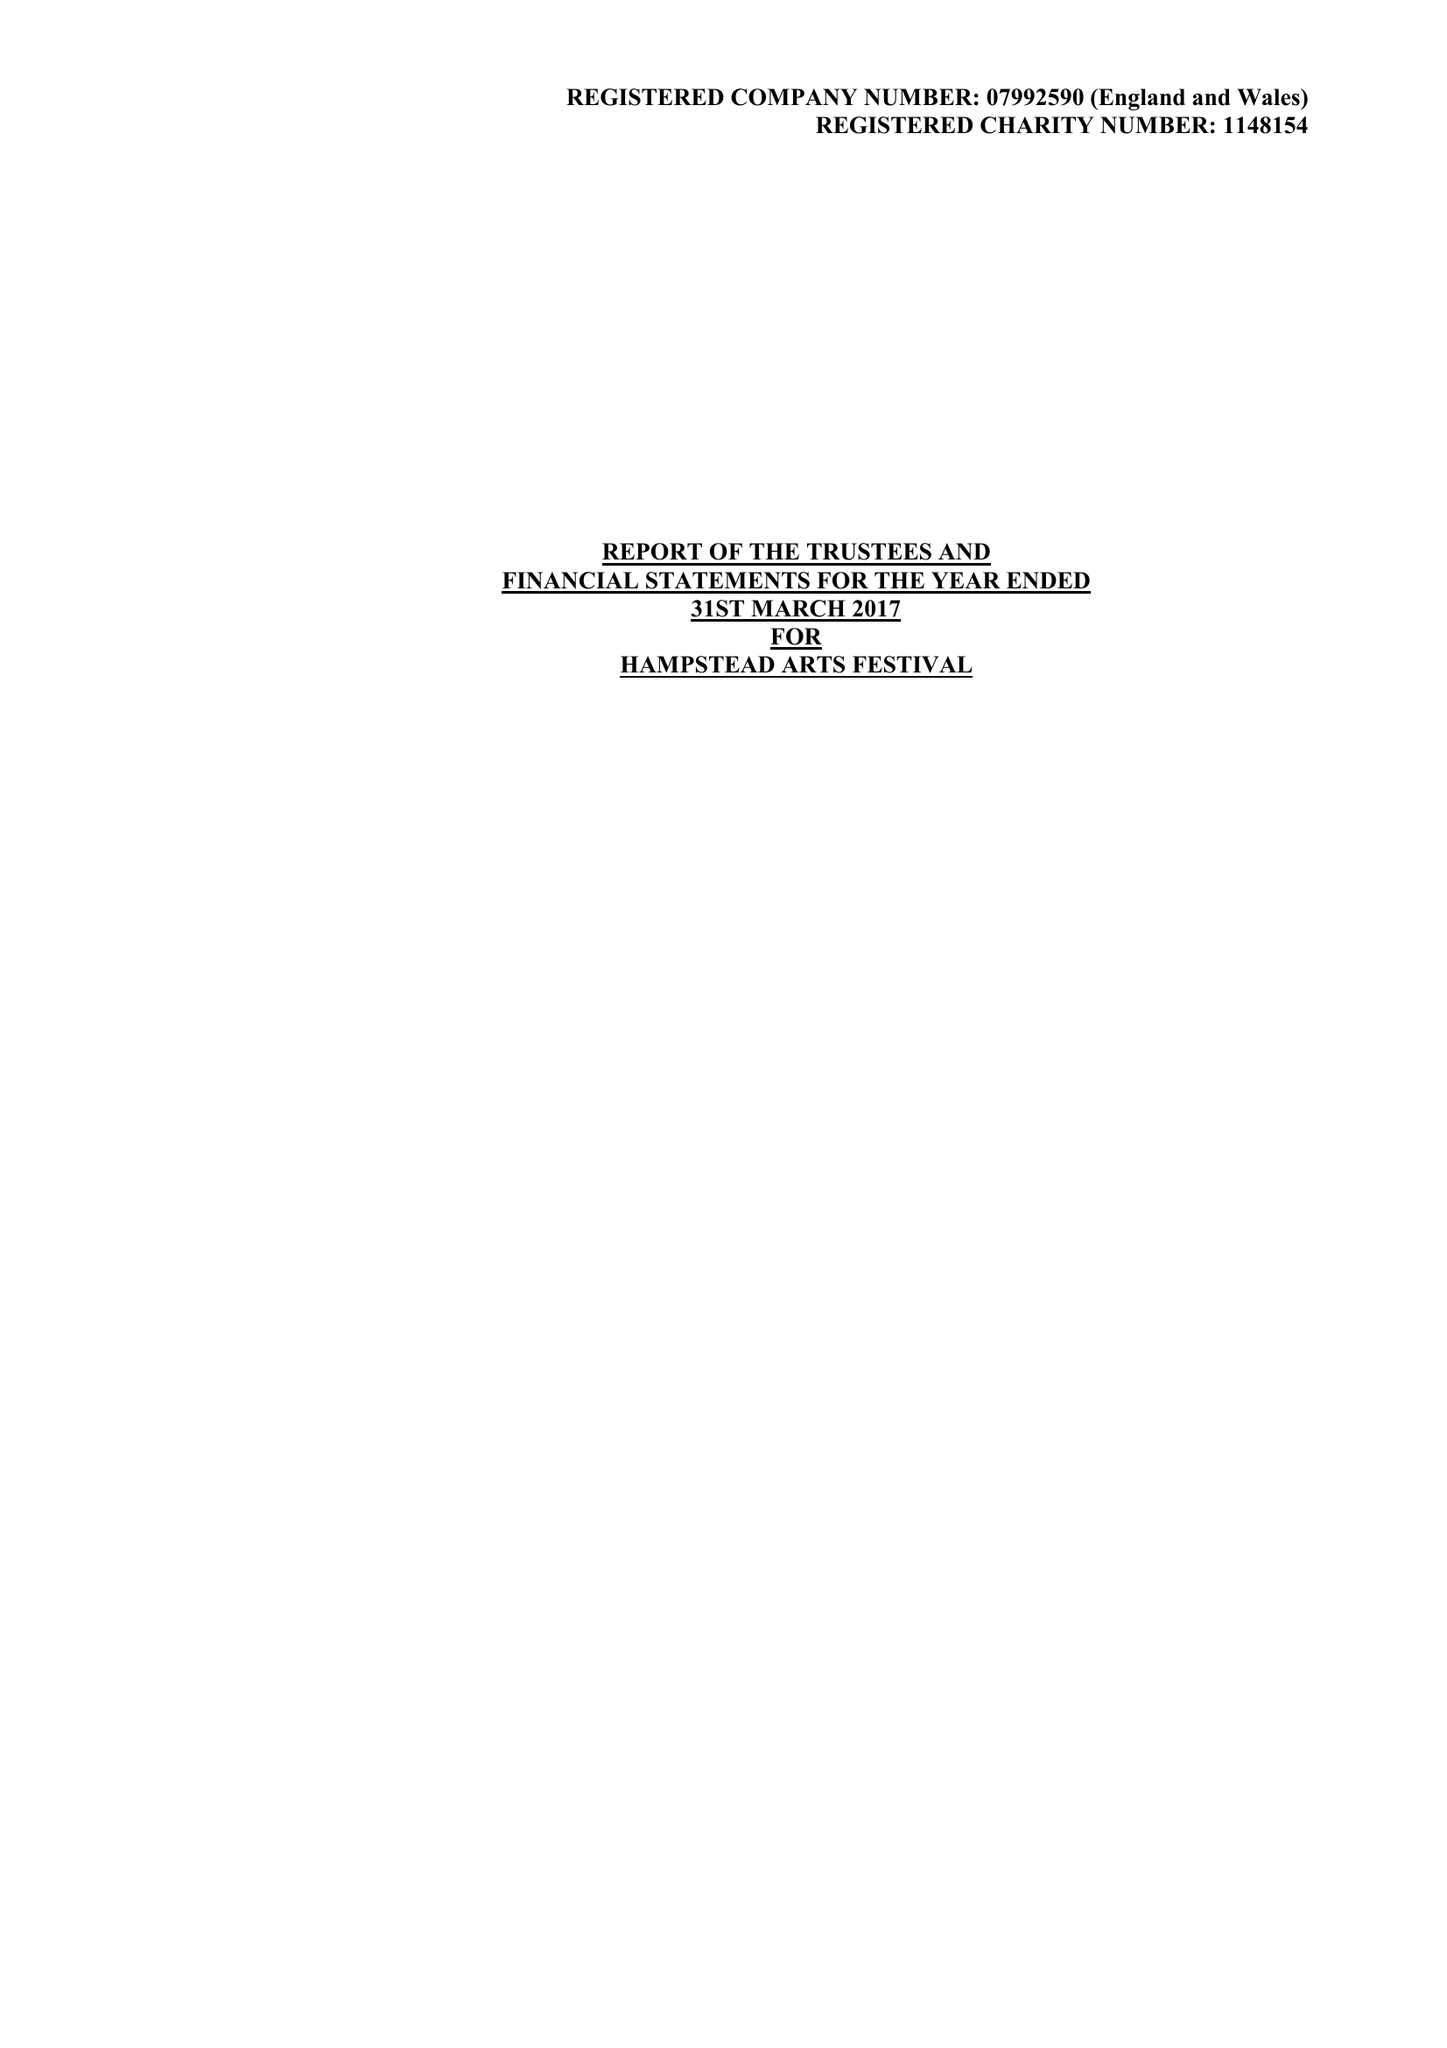What is the value for the address__postcode?
Answer the question using a single word or phrase. HA1 1EJ 